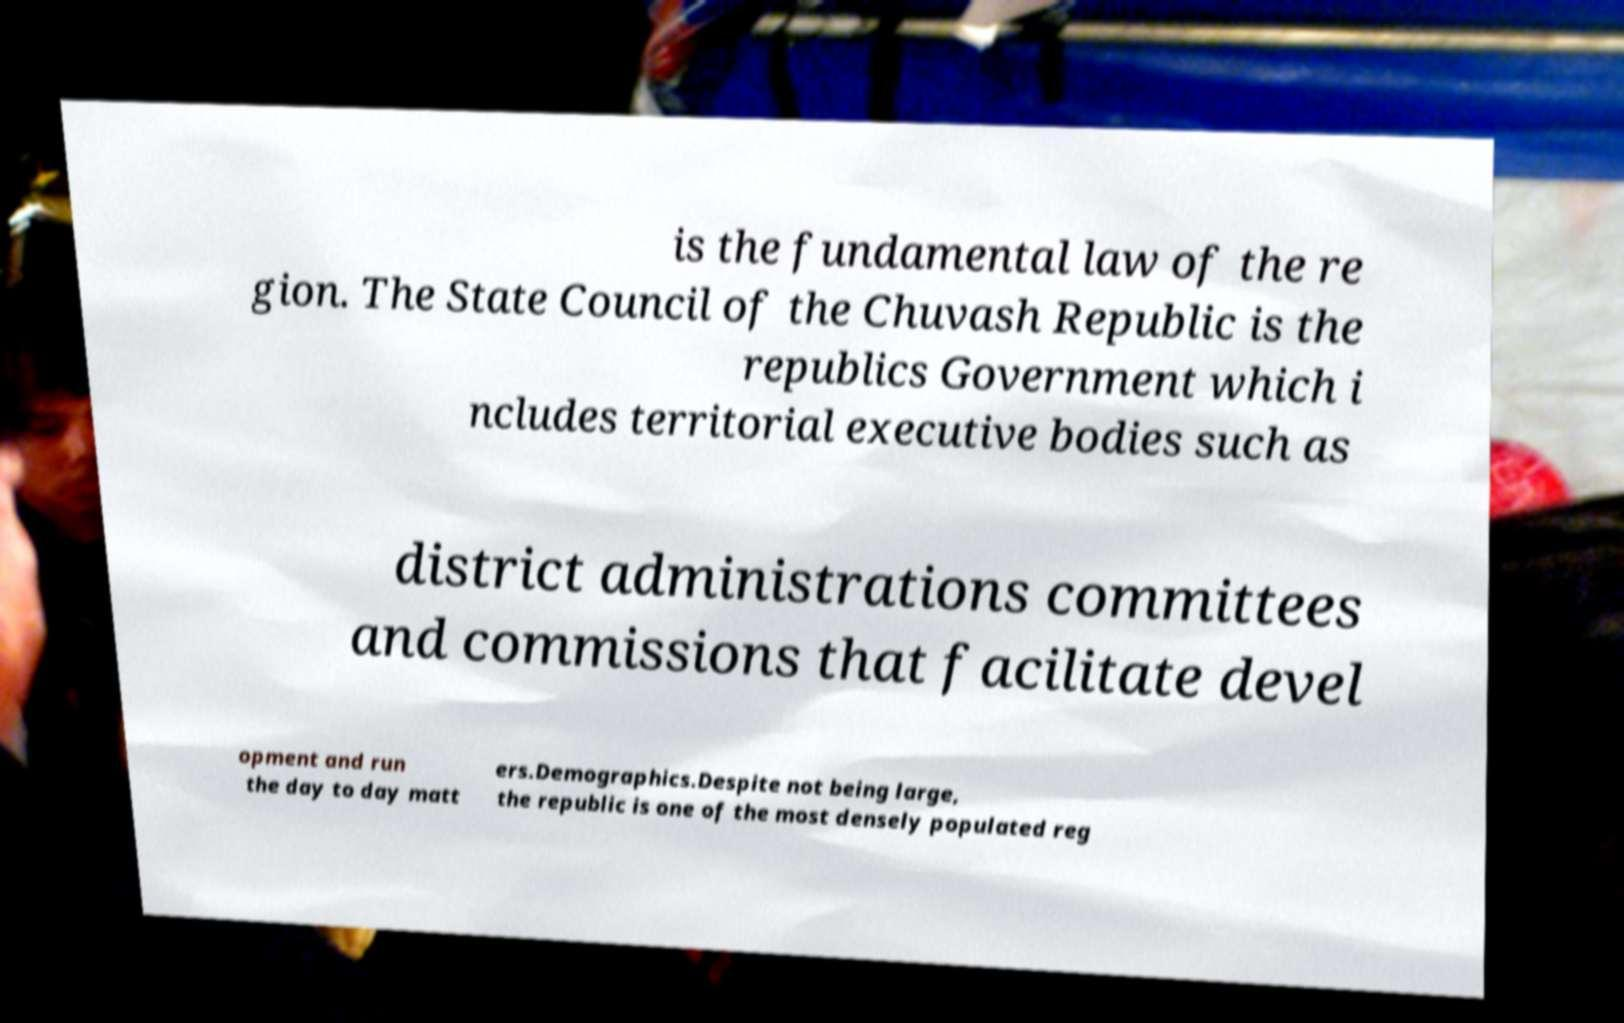Can you accurately transcribe the text from the provided image for me? is the fundamental law of the re gion. The State Council of the Chuvash Republic is the republics Government which i ncludes territorial executive bodies such as district administrations committees and commissions that facilitate devel opment and run the day to day matt ers.Demographics.Despite not being large, the republic is one of the most densely populated reg 